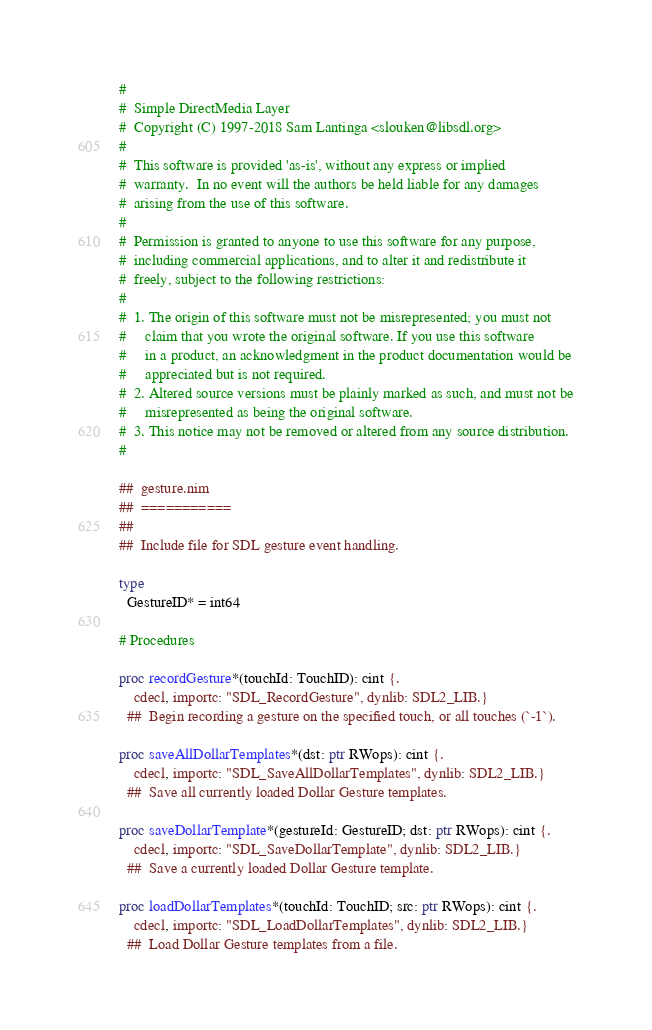Convert code to text. <code><loc_0><loc_0><loc_500><loc_500><_Nim_>#
#  Simple DirectMedia Layer
#  Copyright (C) 1997-2018 Sam Lantinga <slouken@libsdl.org>
#
#  This software is provided 'as-is', without any express or implied
#  warranty.  In no event will the authors be held liable for any damages
#  arising from the use of this software.
#
#  Permission is granted to anyone to use this software for any purpose,
#  including commercial applications, and to alter it and redistribute it
#  freely, subject to the following restrictions:
#
#  1. The origin of this software must not be misrepresented; you must not
#     claim that you wrote the original software. If you use this software
#     in a product, an acknowledgment in the product documentation would be
#     appreciated but is not required.
#  2. Altered source versions must be plainly marked as such, and must not be
#     misrepresented as being the original software.
#  3. This notice may not be removed or altered from any source distribution.
#

##  gesture.nim
##  ===========
##
##  Include file for SDL gesture event handling.

type
  GestureID* = int64

# Procedures

proc recordGesture*(touchId: TouchID): cint {.
    cdecl, importc: "SDL_RecordGesture", dynlib: SDL2_LIB.}
  ##  Begin recording a gesture on the specified touch, or all touches (`-1`).

proc saveAllDollarTemplates*(dst: ptr RWops): cint {.
    cdecl, importc: "SDL_SaveAllDollarTemplates", dynlib: SDL2_LIB.}
  ##  Save all currently loaded Dollar Gesture templates.

proc saveDollarTemplate*(gestureId: GestureID; dst: ptr RWops): cint {.
    cdecl, importc: "SDL_SaveDollarTemplate", dynlib: SDL2_LIB.}
  ##  Save a currently loaded Dollar Gesture template.

proc loadDollarTemplates*(touchId: TouchID; src: ptr RWops): cint {.
    cdecl, importc: "SDL_LoadDollarTemplates", dynlib: SDL2_LIB.}
  ##  Load Dollar Gesture templates from a file.
</code> 